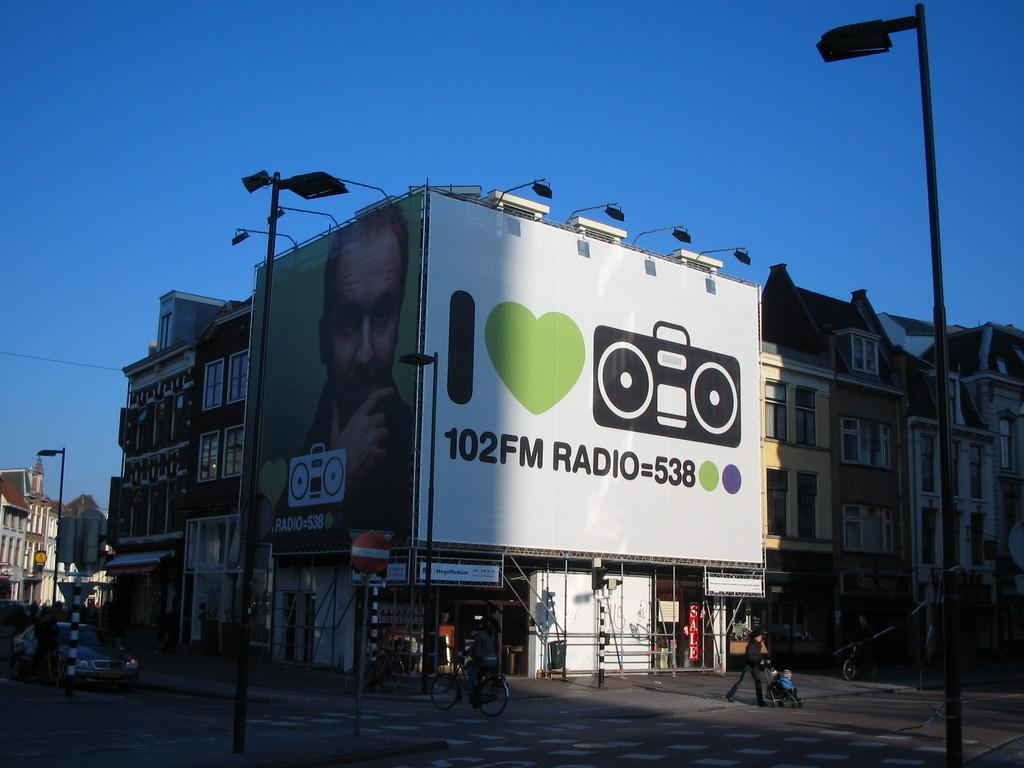<image>
Give a short and clear explanation of the subsequent image. Two billboards on a building with I Heart Radio and the other of a man with a boombox. 